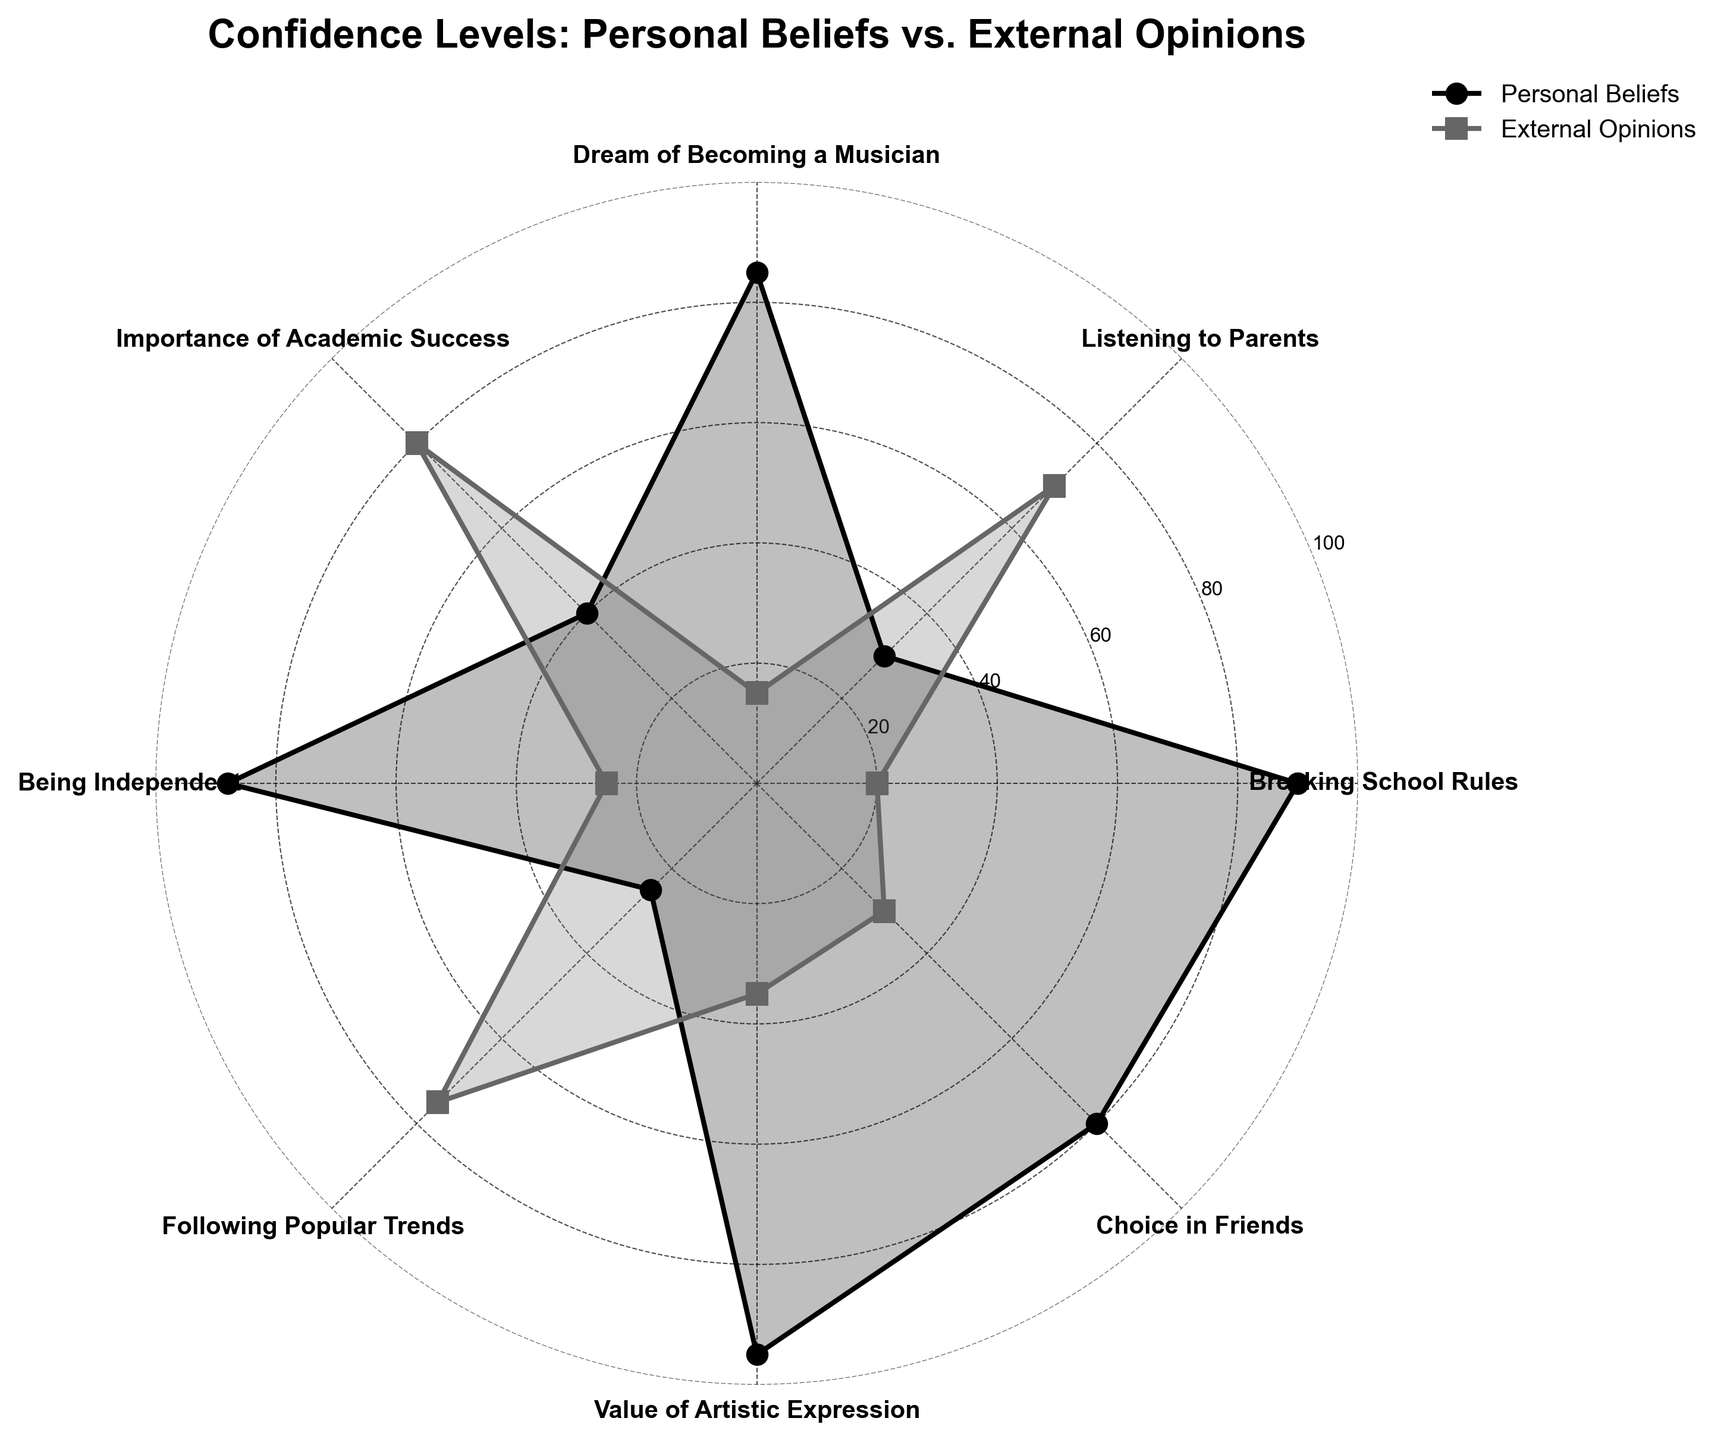When comparing confidence levels in breaking school rules, which perspective is higher? By analyzing the angles corresponding to "Breaking School Rules," we see that the personal beliefs line is at 90, whereas the external opinions line is at 20. Therefore, the confidence level in breaking school rules is higher in personal beliefs.
Answer: Personal Beliefs What's the average confidence level in listening to parents between personal beliefs and external opinions? The values for "Listening to Parents" are 30 for personal beliefs and 70 for external opinions. The average is calculated by (30 + 70) / 2.
Answer: 50 Is the confidence in becoming a musician based more on personal beliefs or external opinions? By examining the angle for "Dream of Becoming a Musician," we see that the personal beliefs line is significantly higher at 85 compared to the external opinions line at 15.
Answer: Personal Beliefs Which category shows the greatest difference between personal beliefs and external opinions? To find this, we have to look at the differences for each category: Breaking School Rules (90 - 20 = 70), Listening to Parents (70 - 30 = 40), Dream of Becoming a Musician (85 - 15 = 70), Importance of Academic Success (80 - 40 = 40), Being Independent (88 - 25 = 63), Following Popular Trends (75 - 25 = 50), Value of Artistic Expression (95 - 35 = 60), Choice in Friends (80 - 30 = 50). The highest difference is 70 for "Breaking School Rules" and "Dream of Becoming a Musician."
Answer: Breaking School Rules and Dream of Becoming a Musician How many categories have higher confidence in personal beliefs than in external opinions? By comparing each category, we see that personal beliefs are higher in Breaking School Rules, Dream of Becoming a Musician, Being Independent, Value of Artistic Expression, and Choice in Friends.
The count is 5.
Answer: 5 Which category shows the lowest confidence in personal beliefs? Looking at all the categories, the lowest personal belief point is for "Listening to Parents" at 30.
Answer: Listening to Parents What is the difference in confidence levels between personal beliefs and external opinions for "Value of Artistic Expression"? The confidence levels for "Value of Artistic Expression" are 95 for personal beliefs and 35 for external opinions. The difference is 95 - 35.
Answer: 60 In which category do external opinions dominate the most significantly over personal beliefs? By observing the plotting points, "Importance of Academic Success" shows a significant domination of external opinions (80) over personal beliefs (40), with a difference of 40.
Answer: Importance of Academic Success What is the median confidence level in external opinions across all categories? Arranging the external opinions values: 15, 20, 25, 30, 35, 70, 75, 80. With an even number of values, the median is the average of the 4th and 5th values (30 + 35) / 2.
Answer: 32.5 